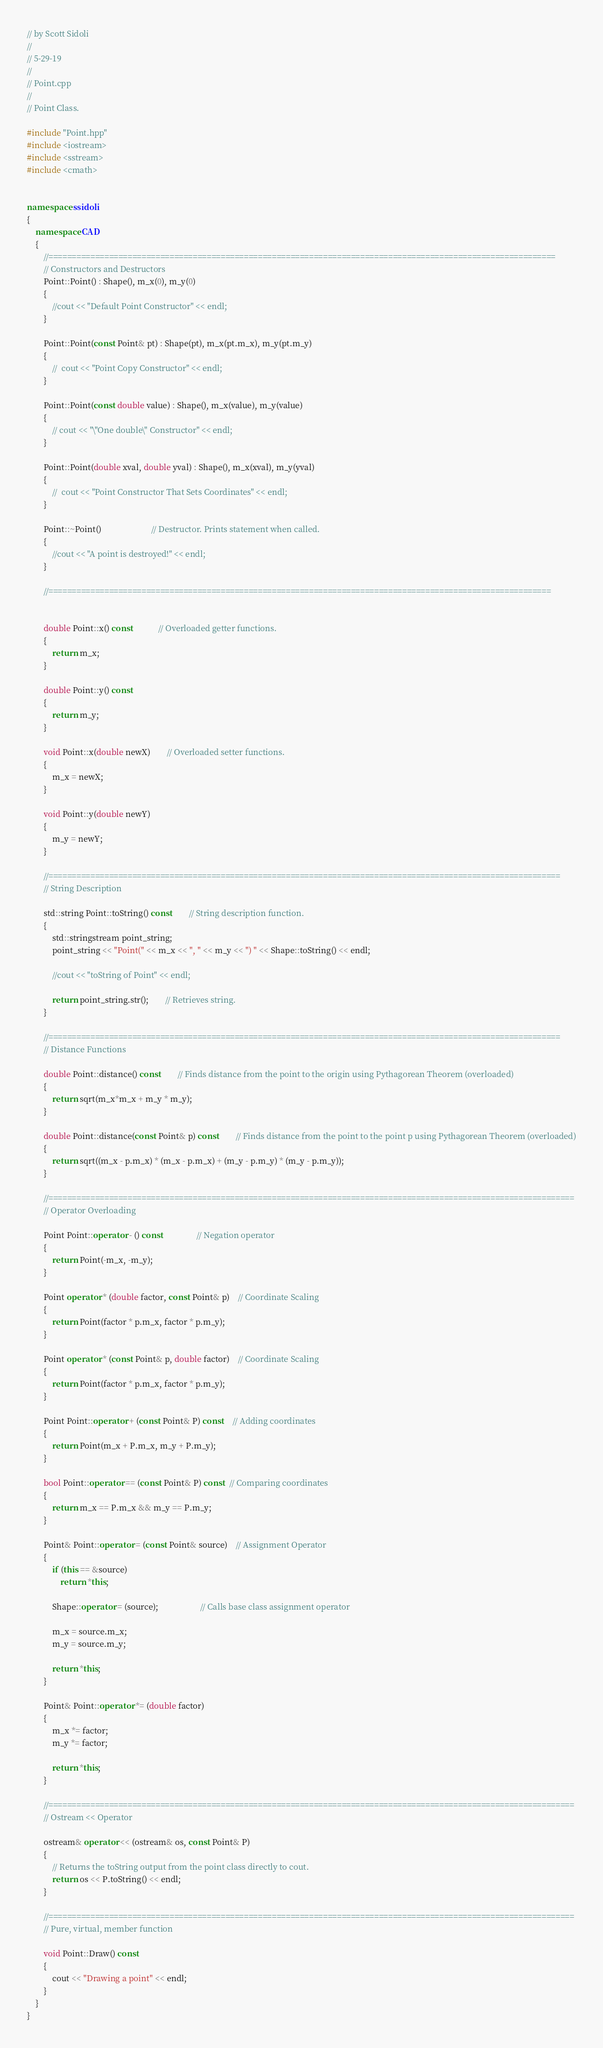Convert code to text. <code><loc_0><loc_0><loc_500><loc_500><_C++_>// by Scott Sidoli
//
// 5-29-19
//
// Point.cpp
// 
// Point Class.

#include "Point.hpp"
#include <iostream>
#include <sstream>
#include <cmath>								


namespace ssidoli
{
	namespace CAD
	{
		//=============================================================================================================
		// Constructors and Destructors
		Point::Point() : Shape(), m_x(0), m_y(0)
		{
			//cout << "Default Point Constructor" << endl;
		}

		Point::Point(const Point& pt) : Shape(pt), m_x(pt.m_x), m_y(pt.m_y)
		{
			//	cout << "Point Copy Constructor" << endl;
		}

		Point::Point(const double value) : Shape(), m_x(value), m_y(value)
		{
			// cout << "\"One double\" Constructor" << endl;
		}

		Point::Point(double xval, double yval) : Shape(), m_x(xval), m_y(yval)
		{
			//	cout << "Point Constructor That Sets Coordinates" << endl;
		}

		Point::~Point()						// Destructor. Prints statement when called.
		{
			//cout << "A point is destroyed!" << endl;
		}

		//============================================================================================================


		double Point::x() const			// Overloaded getter functions.
		{
			return m_x;
		}

		double Point::y() const
		{
			return m_y;
		}

		void Point::x(double newX)		// Overloaded setter functions.
		{
			m_x = newX;
		}

		void Point::y(double newY)
		{
			m_y = newY;
		}

		//==============================================================================================================
		// String Description

		std::string Point::toString() const		// String description function.
		{
			std::stringstream point_string;
			point_string << "Point(" << m_x << ", " << m_y << ") " << Shape::toString() << endl;

			//cout << "toString of Point" << endl;

			return point_string.str();		// Retrieves string.
		}

		//==============================================================================================================
		// Distance Functions

		double Point::distance() const		// Finds distance from the point to the origin using Pythagorean Theorem (overloaded)
		{
			return sqrt(m_x*m_x + m_y * m_y);
		}

		double Point::distance(const Point& p) const		// Finds distance from the point to the point p using Pythagorean Theorem (overloaded)
		{
			return sqrt((m_x - p.m_x) * (m_x - p.m_x) + (m_y - p.m_y) * (m_y - p.m_y));
		}

		//=================================================================================================================
		// Operator Overloading

		Point Point::operator - () const				// Negation operator
		{
			return Point(-m_x, -m_y);
		}

		Point operator * (double factor, const Point& p)	// Coordinate Scaling
		{
			return Point(factor * p.m_x, factor * p.m_y);
		}

		Point operator * (const Point& p, double factor)	// Coordinate Scaling
		{
			return Point(factor * p.m_x, factor * p.m_y);
		}

		Point Point::operator + (const Point& P) const	// Adding coordinates
		{
			return Point(m_x + P.m_x, m_y + P.m_y);
		}

		bool Point::operator == (const Point& P) const  // Comparing coordinates
		{
			return m_x == P.m_x && m_y == P.m_y;
		}

		Point& Point::operator = (const Point& source)	// Assignment Operator
		{
			if (this == &source)
				return *this;

			Shape::operator = (source);					// Calls base class assignment operator

			m_x = source.m_x;
			m_y = source.m_y;

			return *this;
		}

		Point& Point::operator *= (double factor)
		{
			m_x *= factor;
			m_y *= factor;

			return *this;
		}

		//=================================================================================================================
		// Ostream << Operator

		ostream& operator << (ostream& os, const Point& P)
		{
			// Returns the toString output from the point class directly to cout.
			return os << P.toString() << endl;
		}

		//=================================================================================================================
		// Pure, virtual, member function

		void Point::Draw() const
		{
			cout << "Drawing a point" << endl;
		}
	}
}</code> 